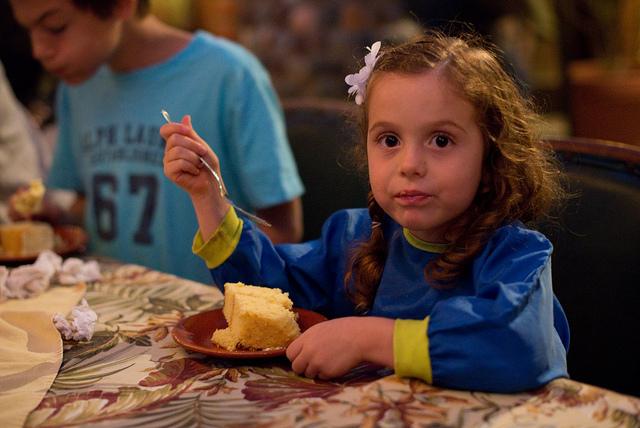Do you think this is a snack?
Give a very brief answer. Yes. How old is this little girl?
Keep it brief. 5. Are they eating with clean or dirty hands?
Answer briefly. Clean. Is this pizza?
Write a very short answer. No. Is this a girl or a boy?
Quick response, please. Girl. What dessert is the girl eating?
Concise answer only. Cake. Are the people using eating utensils?
Keep it brief. Yes. Is the cake frosted?
Give a very brief answer. No. Is the girl eating with a spoon?
Answer briefly. No. How many elbows are on the table?
Give a very brief answer. 2. Is there any juice on the table?
Be succinct. No. Could they now be married?
Short answer required. No. How many of the children are boys?
Answer briefly. 1. Is the little girls hair in curls?
Keep it brief. Yes. Are both of the people from the same generation?
Write a very short answer. Yes. How many hot dogs will this person be eating?
Be succinct. 1. 